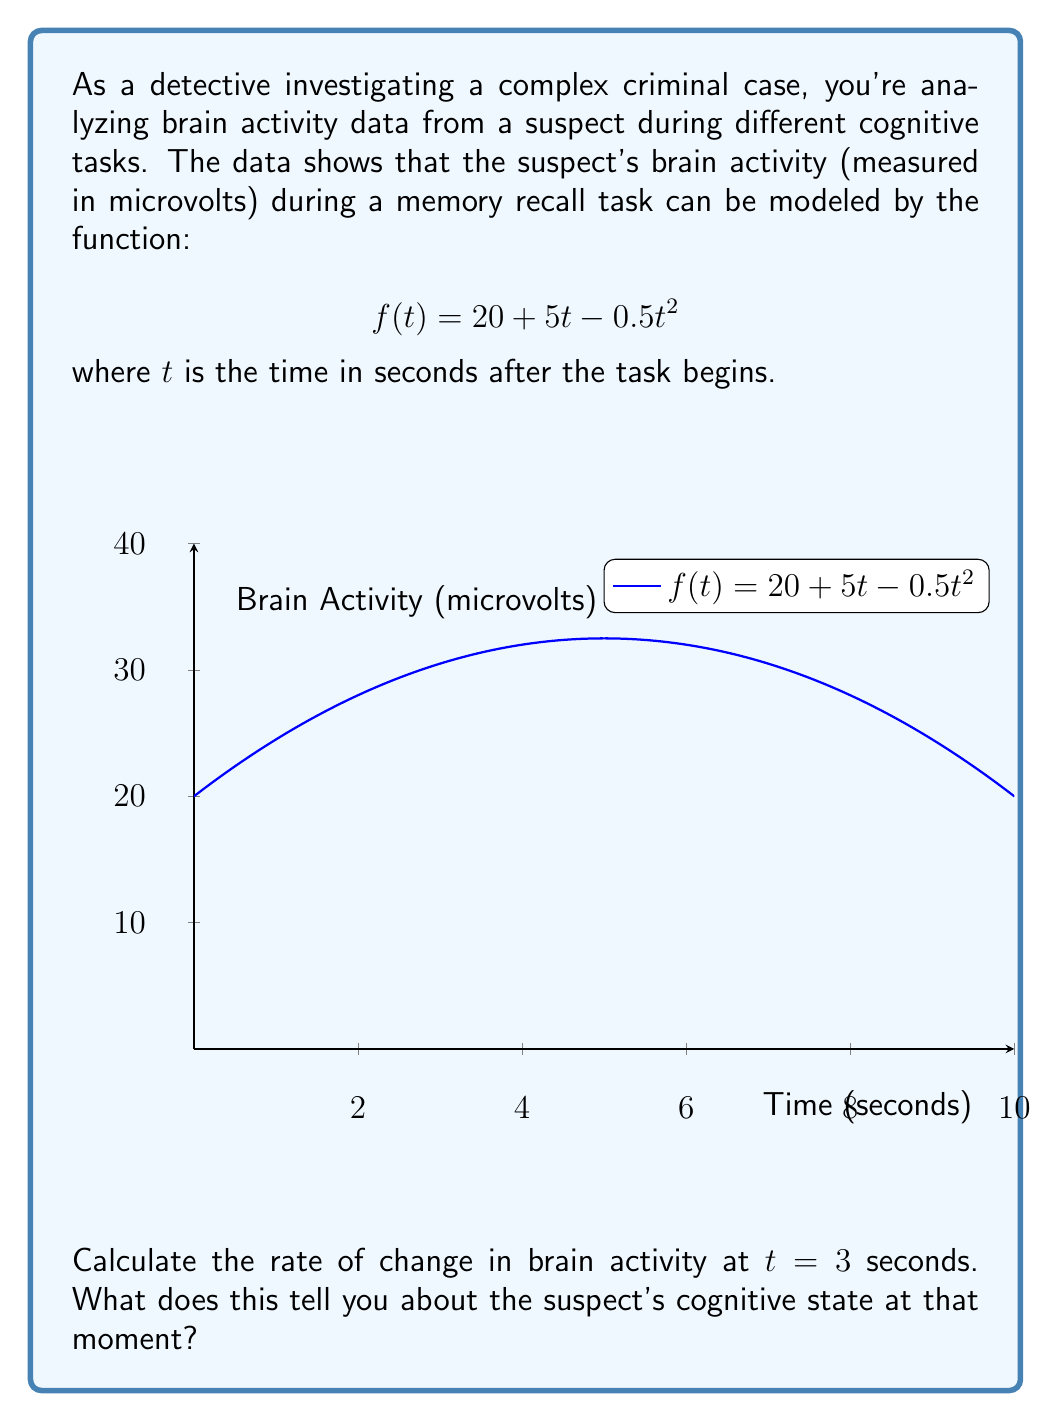Can you solve this math problem? To solve this problem, we need to find the derivative of the function $f(t)$ and evaluate it at $t = 3$ seconds. This will give us the instantaneous rate of change of brain activity at that moment.

Step 1: Find the derivative of $f(t)$.
$$f(t) = 20 + 5t - 0.5t^2$$
$$f'(t) = 5 - t$$

Step 2: Evaluate $f'(t)$ at $t = 3$.
$$f'(3) = 5 - 3 = 2$$

Step 3: Interpret the result.
The rate of change at $t = 3$ seconds is 2 microvolts per second. This positive value indicates that the brain activity is still increasing at this point, but at a slower rate than initially (since the function is quadratic and concave down).

From a detective's perspective, this suggests that the suspect's cognitive engagement in the memory recall task is still rising at the 3-second mark. However, the rate of increase is slowing down, which might indicate that the suspect is approaching peak concentration or starting to fatigue.
Answer: 2 microvolts/second 